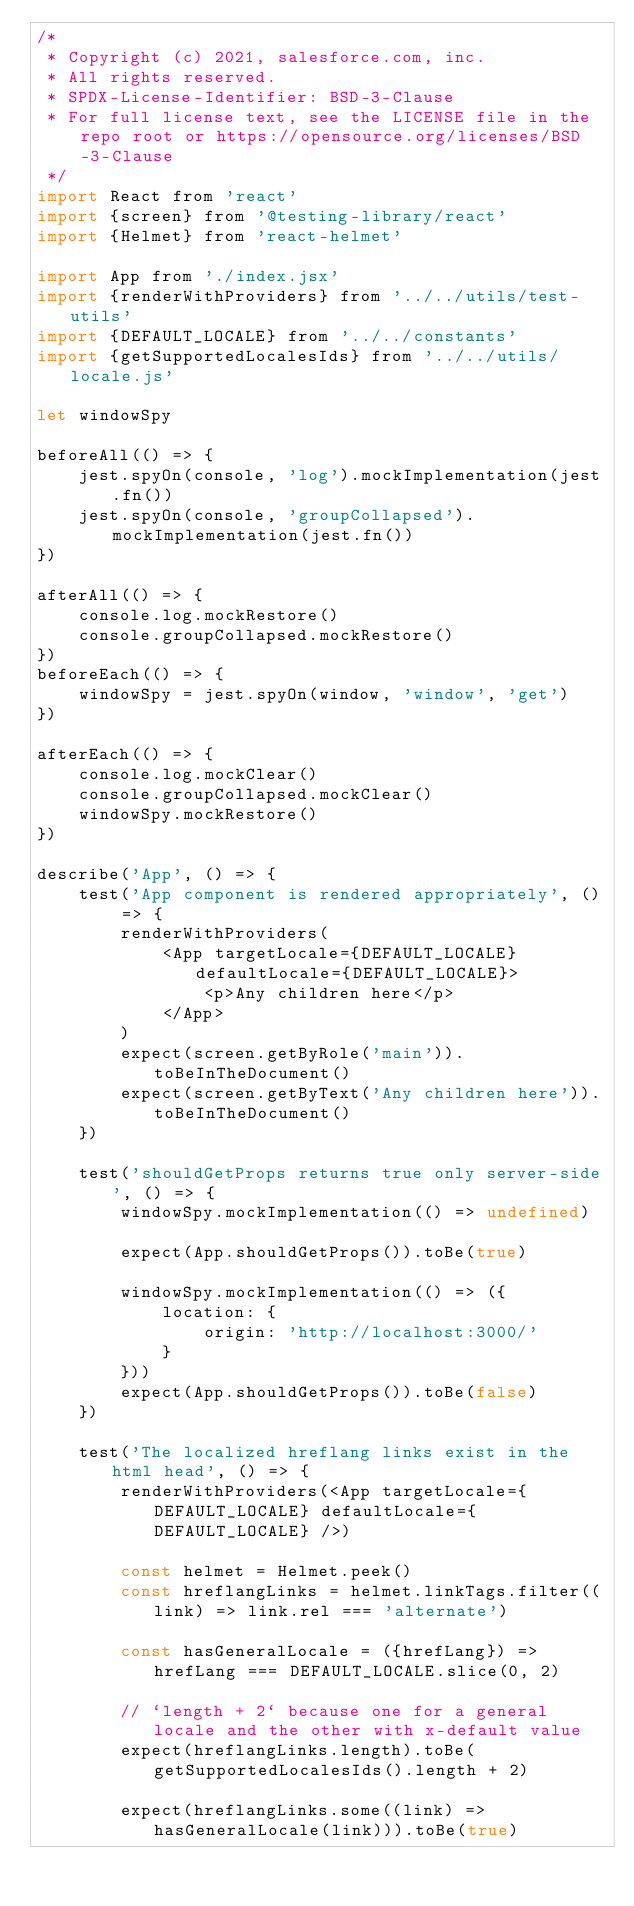Convert code to text. <code><loc_0><loc_0><loc_500><loc_500><_JavaScript_>/*
 * Copyright (c) 2021, salesforce.com, inc.
 * All rights reserved.
 * SPDX-License-Identifier: BSD-3-Clause
 * For full license text, see the LICENSE file in the repo root or https://opensource.org/licenses/BSD-3-Clause
 */
import React from 'react'
import {screen} from '@testing-library/react'
import {Helmet} from 'react-helmet'

import App from './index.jsx'
import {renderWithProviders} from '../../utils/test-utils'
import {DEFAULT_LOCALE} from '../../constants'
import {getSupportedLocalesIds} from '../../utils/locale.js'

let windowSpy

beforeAll(() => {
    jest.spyOn(console, 'log').mockImplementation(jest.fn())
    jest.spyOn(console, 'groupCollapsed').mockImplementation(jest.fn())
})

afterAll(() => {
    console.log.mockRestore()
    console.groupCollapsed.mockRestore()
})
beforeEach(() => {
    windowSpy = jest.spyOn(window, 'window', 'get')
})

afterEach(() => {
    console.log.mockClear()
    console.groupCollapsed.mockClear()
    windowSpy.mockRestore()
})

describe('App', () => {
    test('App component is rendered appropriately', () => {
        renderWithProviders(
            <App targetLocale={DEFAULT_LOCALE} defaultLocale={DEFAULT_LOCALE}>
                <p>Any children here</p>
            </App>
        )
        expect(screen.getByRole('main')).toBeInTheDocument()
        expect(screen.getByText('Any children here')).toBeInTheDocument()
    })

    test('shouldGetProps returns true only server-side', () => {
        windowSpy.mockImplementation(() => undefined)

        expect(App.shouldGetProps()).toBe(true)

        windowSpy.mockImplementation(() => ({
            location: {
                origin: 'http://localhost:3000/'
            }
        }))
        expect(App.shouldGetProps()).toBe(false)
    })

    test('The localized hreflang links exist in the html head', () => {
        renderWithProviders(<App targetLocale={DEFAULT_LOCALE} defaultLocale={DEFAULT_LOCALE} />)

        const helmet = Helmet.peek()
        const hreflangLinks = helmet.linkTags.filter((link) => link.rel === 'alternate')

        const hasGeneralLocale = ({hrefLang}) => hrefLang === DEFAULT_LOCALE.slice(0, 2)

        // `length + 2` because one for a general locale and the other with x-default value
        expect(hreflangLinks.length).toBe(getSupportedLocalesIds().length + 2)

        expect(hreflangLinks.some((link) => hasGeneralLocale(link))).toBe(true)</code> 